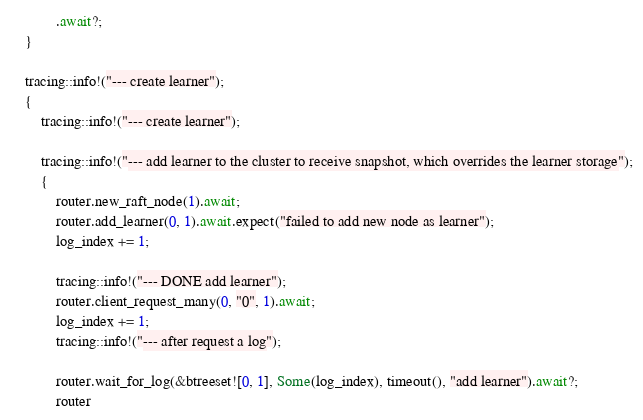<code> <loc_0><loc_0><loc_500><loc_500><_Rust_>            .await?;
    }

    tracing::info!("--- create learner");
    {
        tracing::info!("--- create learner");

        tracing::info!("--- add learner to the cluster to receive snapshot, which overrides the learner storage");
        {
            router.new_raft_node(1).await;
            router.add_learner(0, 1).await.expect("failed to add new node as learner");
            log_index += 1;

            tracing::info!("--- DONE add learner");
            router.client_request_many(0, "0", 1).await;
            log_index += 1;
            tracing::info!("--- after request a log");

            router.wait_for_log(&btreeset![0, 1], Some(log_index), timeout(), "add learner").await?;
            router</code> 